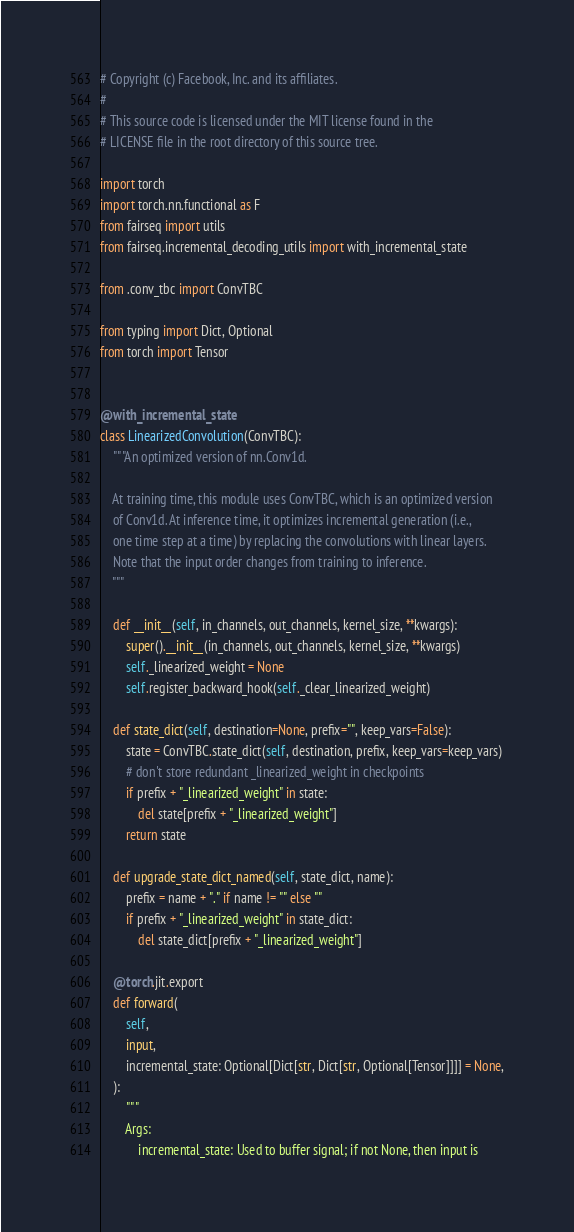<code> <loc_0><loc_0><loc_500><loc_500><_Python_># Copyright (c) Facebook, Inc. and its affiliates.
#
# This source code is licensed under the MIT license found in the
# LICENSE file in the root directory of this source tree.

import torch
import torch.nn.functional as F
from fairseq import utils
from fairseq.incremental_decoding_utils import with_incremental_state

from .conv_tbc import ConvTBC

from typing import Dict, Optional
from torch import Tensor


@with_incremental_state
class LinearizedConvolution(ConvTBC):
    """An optimized version of nn.Conv1d.

    At training time, this module uses ConvTBC, which is an optimized version
    of Conv1d. At inference time, it optimizes incremental generation (i.e.,
    one time step at a time) by replacing the convolutions with linear layers.
    Note that the input order changes from training to inference.
    """

    def __init__(self, in_channels, out_channels, kernel_size, **kwargs):
        super().__init__(in_channels, out_channels, kernel_size, **kwargs)
        self._linearized_weight = None
        self.register_backward_hook(self._clear_linearized_weight)

    def state_dict(self, destination=None, prefix="", keep_vars=False):
        state = ConvTBC.state_dict(self, destination, prefix, keep_vars=keep_vars)
        # don't store redundant _linearized_weight in checkpoints
        if prefix + "_linearized_weight" in state:
            del state[prefix + "_linearized_weight"]
        return state

    def upgrade_state_dict_named(self, state_dict, name):
        prefix = name + "." if name != "" else ""
        if prefix + "_linearized_weight" in state_dict:
            del state_dict[prefix + "_linearized_weight"]

    @torch.jit.export
    def forward(
        self,
        input,
        incremental_state: Optional[Dict[str, Dict[str, Optional[Tensor]]]] = None,
    ):
        """
        Args:
            incremental_state: Used to buffer signal; if not None, then input is</code> 